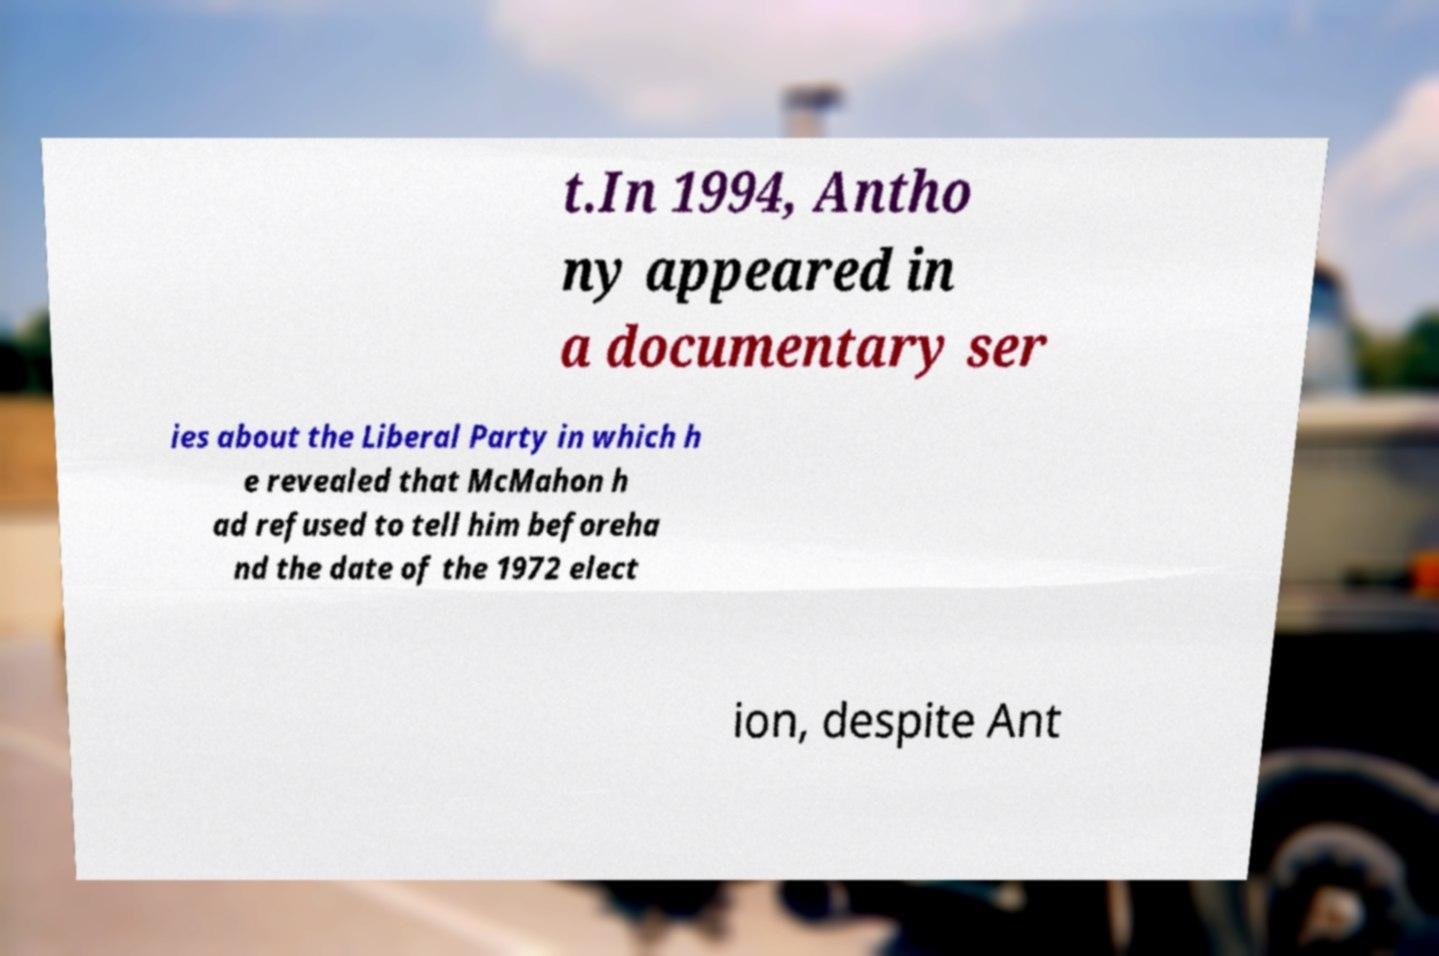Please identify and transcribe the text found in this image. t.In 1994, Antho ny appeared in a documentary ser ies about the Liberal Party in which h e revealed that McMahon h ad refused to tell him beforeha nd the date of the 1972 elect ion, despite Ant 